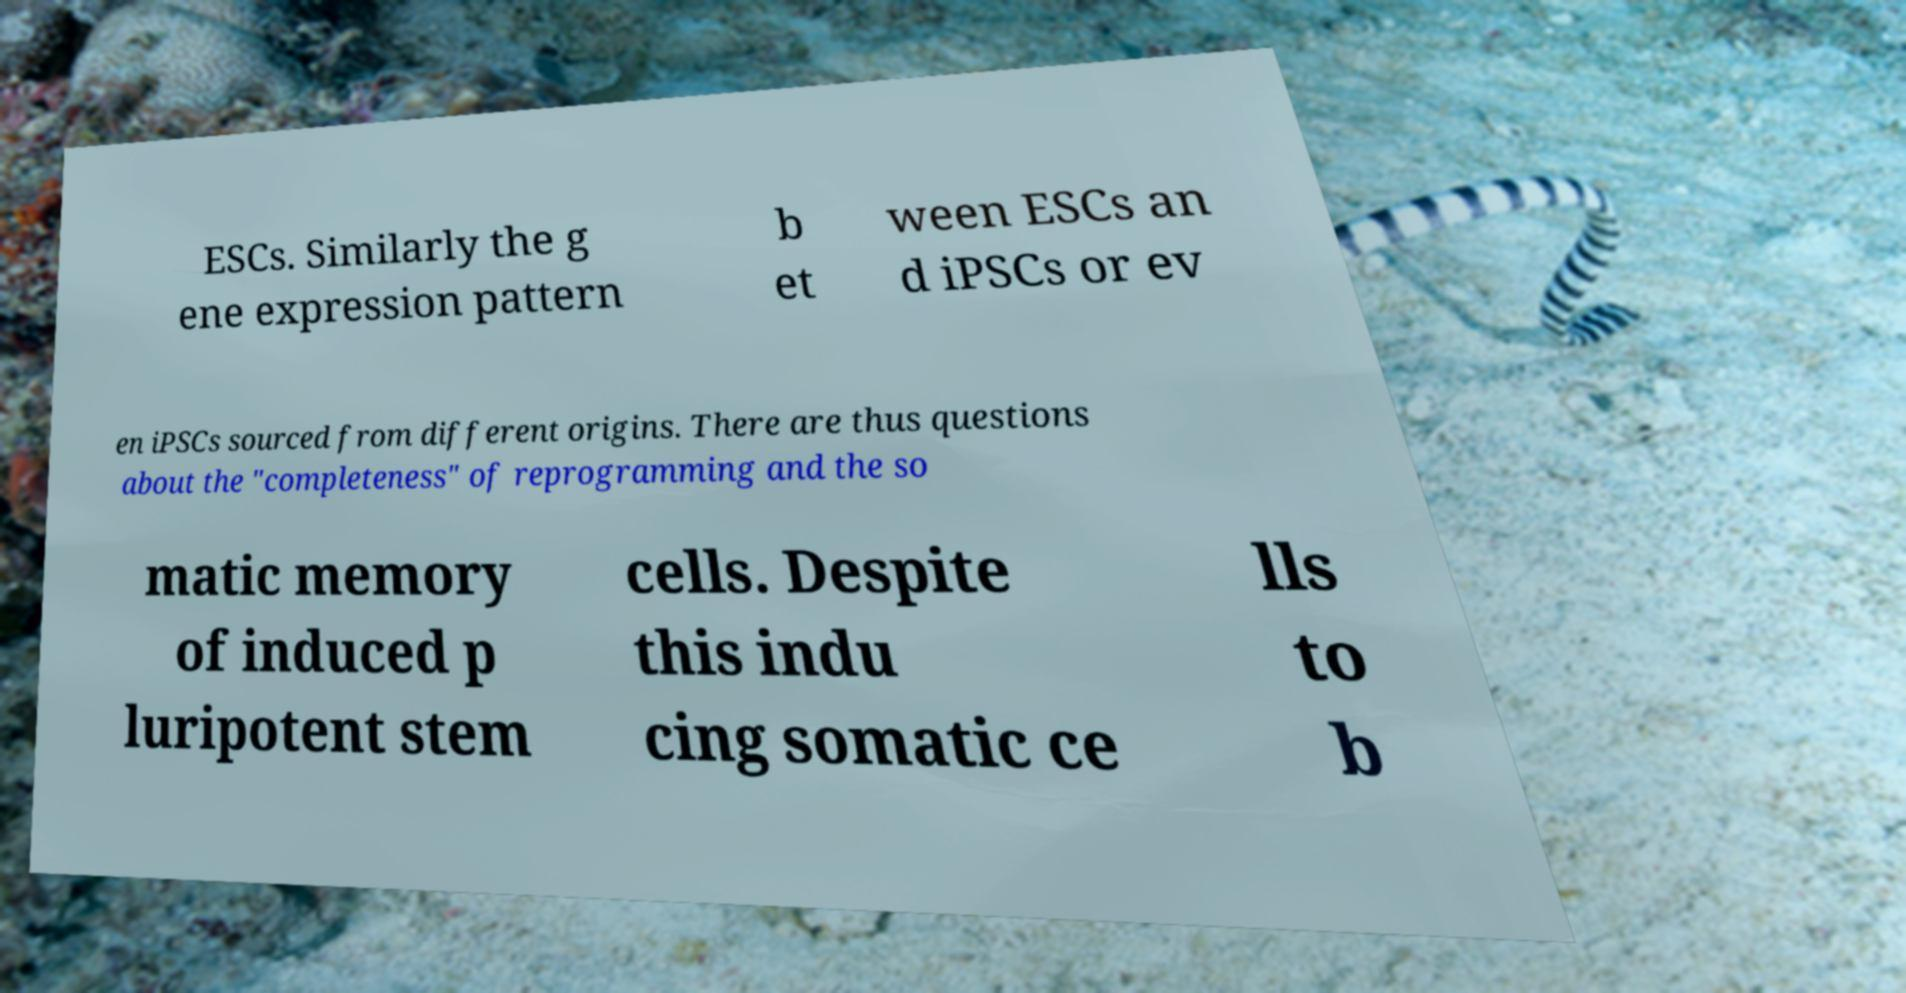Can you read and provide the text displayed in the image?This photo seems to have some interesting text. Can you extract and type it out for me? ESCs. Similarly the g ene expression pattern b et ween ESCs an d iPSCs or ev en iPSCs sourced from different origins. There are thus questions about the "completeness" of reprogramming and the so matic memory of induced p luripotent stem cells. Despite this indu cing somatic ce lls to b 